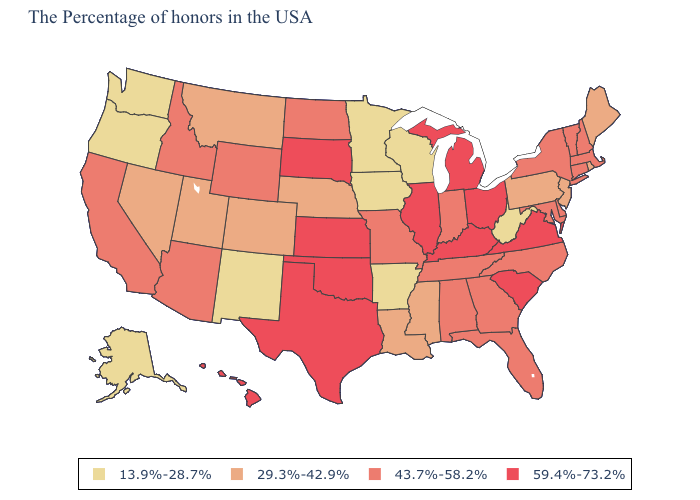What is the highest value in states that border Alabama?
Concise answer only. 43.7%-58.2%. What is the value of Arkansas?
Short answer required. 13.9%-28.7%. Which states have the lowest value in the West?
Write a very short answer. New Mexico, Washington, Oregon, Alaska. What is the lowest value in the USA?
Write a very short answer. 13.9%-28.7%. Name the states that have a value in the range 43.7%-58.2%?
Keep it brief. Massachusetts, New Hampshire, Vermont, Connecticut, New York, Delaware, Maryland, North Carolina, Florida, Georgia, Indiana, Alabama, Tennessee, Missouri, North Dakota, Wyoming, Arizona, Idaho, California. Name the states that have a value in the range 43.7%-58.2%?
Concise answer only. Massachusetts, New Hampshire, Vermont, Connecticut, New York, Delaware, Maryland, North Carolina, Florida, Georgia, Indiana, Alabama, Tennessee, Missouri, North Dakota, Wyoming, Arizona, Idaho, California. What is the value of Mississippi?
Quick response, please. 29.3%-42.9%. What is the lowest value in the USA?
Answer briefly. 13.9%-28.7%. Is the legend a continuous bar?
Quick response, please. No. What is the value of Vermont?
Keep it brief. 43.7%-58.2%. Among the states that border South Dakota , which have the lowest value?
Write a very short answer. Minnesota, Iowa. What is the value of Kentucky?
Give a very brief answer. 59.4%-73.2%. Among the states that border Colorado , which have the lowest value?
Be succinct. New Mexico. How many symbols are there in the legend?
Be succinct. 4. Does the map have missing data?
Short answer required. No. 